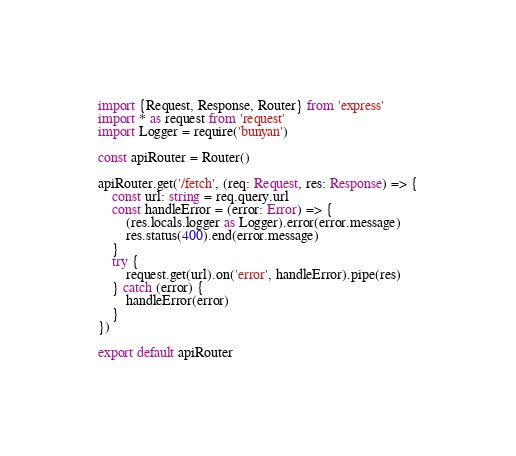Convert code to text. <code><loc_0><loc_0><loc_500><loc_500><_TypeScript_>import {Request, Response, Router} from 'express'
import * as request from 'request'
import Logger = require('bunyan')

const apiRouter = Router()

apiRouter.get('/fetch', (req: Request, res: Response) => {
	const url: string = req.query.url
	const handleError = (error: Error) => {
		(res.locals.logger as Logger).error(error.message)
		res.status(400).end(error.message)
	}
	try {
		request.get(url).on('error', handleError).pipe(res)
	} catch (error) {
		handleError(error)
	}
})

export default apiRouter
</code> 